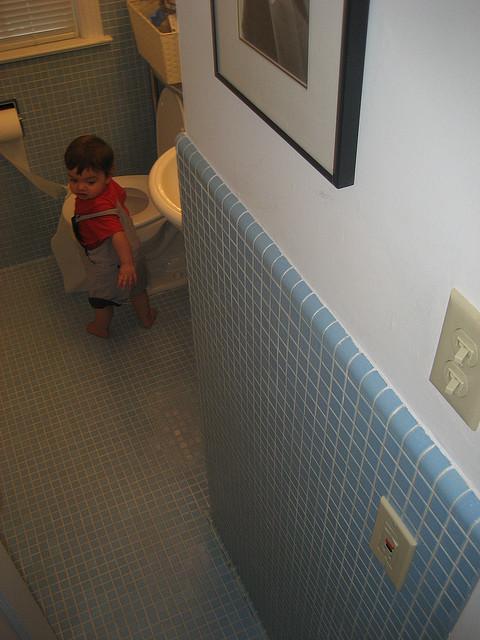What is the boy standing doing?
Keep it brief. Playing. How many boys are not wearing shirts?
Keep it brief. 0. What is the person doing?
Quick response, please. Standing. What color is the tile?
Write a very short answer. Blue. Why is the baby by the toilet?
Answer briefly. Playing with toilet paper. What animal is in the picture?
Quick response, please. Human. How many feet can be seen?
Be succinct. 2. Is the baby happy?
Quick response, please. Yes. What room is this?
Keep it brief. Bathroom. Is the toilet seat up or down?
Be succinct. Down. Could this be a diaper change?
Quick response, please. No. Is his hair long?
Answer briefly. No. Where are the tiles?
Be succinct. Wall. What is the child wearing?
Concise answer only. Overalls. What is the child looking at?
Give a very brief answer. Door. What is the child doing?
Write a very short answer. Playing with toilet paper. 